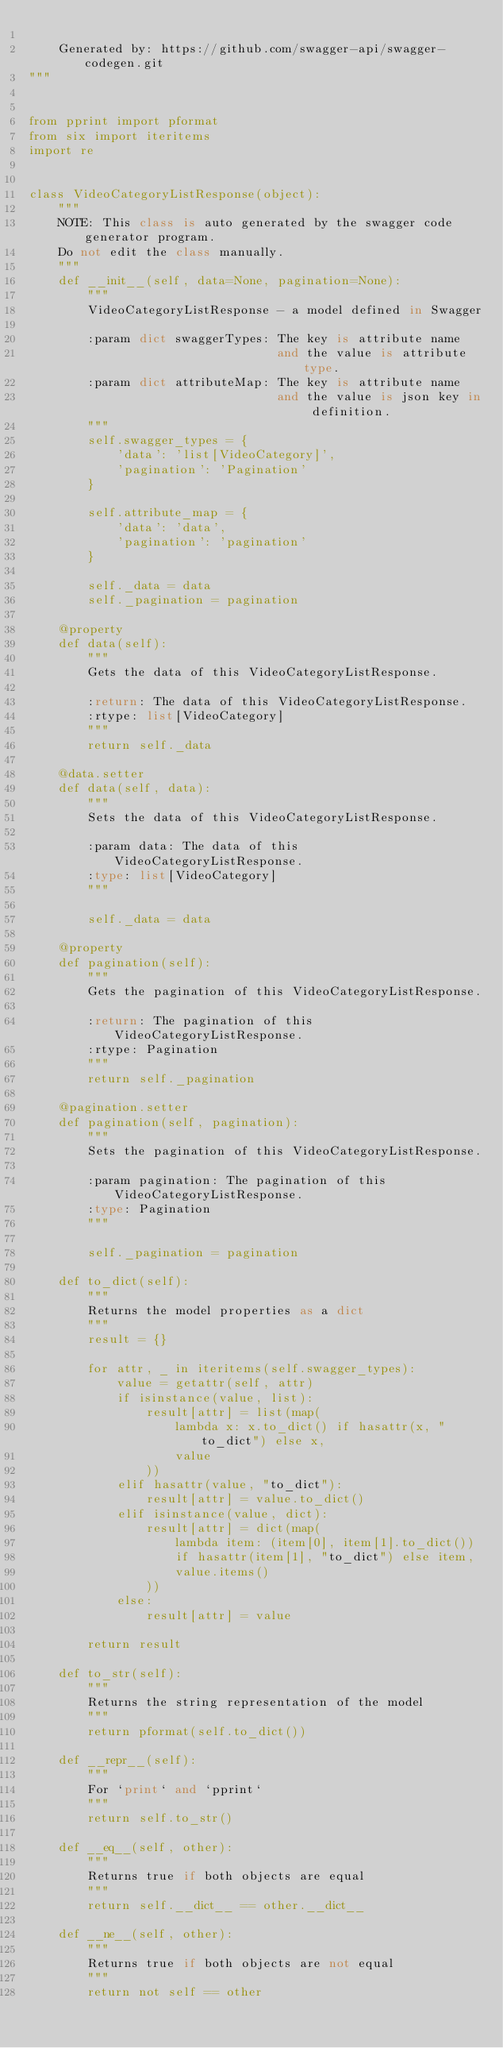<code> <loc_0><loc_0><loc_500><loc_500><_Python_>    
    Generated by: https://github.com/swagger-api/swagger-codegen.git
"""


from pprint import pformat
from six import iteritems
import re


class VideoCategoryListResponse(object):
    """
    NOTE: This class is auto generated by the swagger code generator program.
    Do not edit the class manually.
    """
    def __init__(self, data=None, pagination=None):
        """
        VideoCategoryListResponse - a model defined in Swagger

        :param dict swaggerTypes: The key is attribute name
                                  and the value is attribute type.
        :param dict attributeMap: The key is attribute name
                                  and the value is json key in definition.
        """
        self.swagger_types = {
            'data': 'list[VideoCategory]',
            'pagination': 'Pagination'
        }

        self.attribute_map = {
            'data': 'data',
            'pagination': 'pagination'
        }

        self._data = data
        self._pagination = pagination

    @property
    def data(self):
        """
        Gets the data of this VideoCategoryListResponse.

        :return: The data of this VideoCategoryListResponse.
        :rtype: list[VideoCategory]
        """
        return self._data

    @data.setter
    def data(self, data):
        """
        Sets the data of this VideoCategoryListResponse.

        :param data: The data of this VideoCategoryListResponse.
        :type: list[VideoCategory]
        """

        self._data = data

    @property
    def pagination(self):
        """
        Gets the pagination of this VideoCategoryListResponse.

        :return: The pagination of this VideoCategoryListResponse.
        :rtype: Pagination
        """
        return self._pagination

    @pagination.setter
    def pagination(self, pagination):
        """
        Sets the pagination of this VideoCategoryListResponse.

        :param pagination: The pagination of this VideoCategoryListResponse.
        :type: Pagination
        """

        self._pagination = pagination

    def to_dict(self):
        """
        Returns the model properties as a dict
        """
        result = {}

        for attr, _ in iteritems(self.swagger_types):
            value = getattr(self, attr)
            if isinstance(value, list):
                result[attr] = list(map(
                    lambda x: x.to_dict() if hasattr(x, "to_dict") else x,
                    value
                ))
            elif hasattr(value, "to_dict"):
                result[attr] = value.to_dict()
            elif isinstance(value, dict):
                result[attr] = dict(map(
                    lambda item: (item[0], item[1].to_dict())
                    if hasattr(item[1], "to_dict") else item,
                    value.items()
                ))
            else:
                result[attr] = value

        return result

    def to_str(self):
        """
        Returns the string representation of the model
        """
        return pformat(self.to_dict())

    def __repr__(self):
        """
        For `print` and `pprint`
        """
        return self.to_str()

    def __eq__(self, other):
        """
        Returns true if both objects are equal
        """
        return self.__dict__ == other.__dict__

    def __ne__(self, other):
        """
        Returns true if both objects are not equal
        """
        return not self == other
</code> 